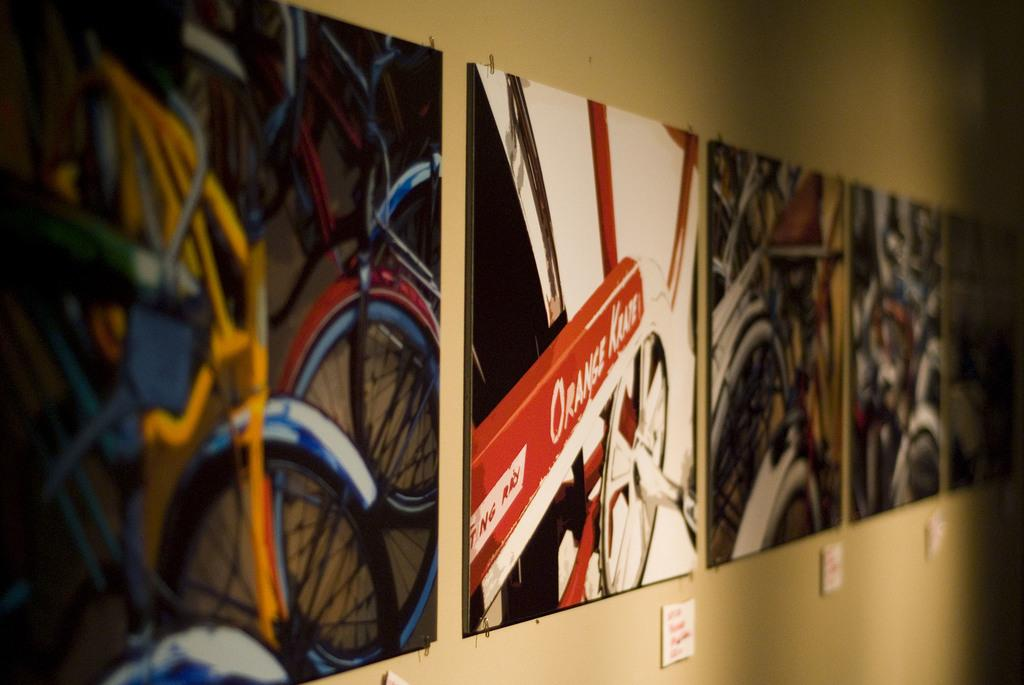What is on the wall in the image? There are posters on the wall in the image. What can be found on the posters? The posters contain both text and images. How many thumbs are visible on the posters in the image? There is no mention of thumbs or any body parts in the image; the posters contain text and images. 